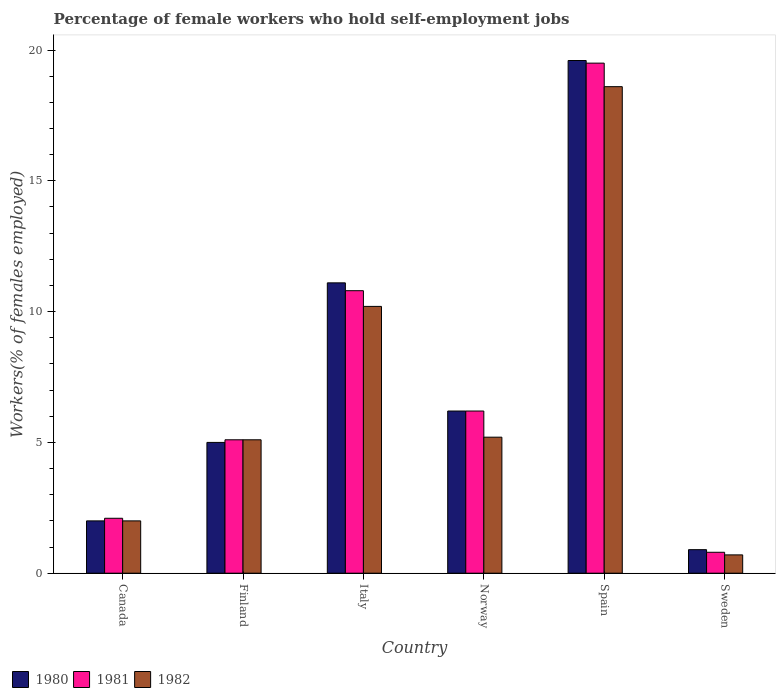How many different coloured bars are there?
Offer a terse response. 3. Are the number of bars per tick equal to the number of legend labels?
Your answer should be compact. Yes. Are the number of bars on each tick of the X-axis equal?
Give a very brief answer. Yes. What is the percentage of self-employed female workers in 1981 in Norway?
Offer a very short reply. 6.2. Across all countries, what is the maximum percentage of self-employed female workers in 1982?
Make the answer very short. 18.6. Across all countries, what is the minimum percentage of self-employed female workers in 1982?
Provide a short and direct response. 0.7. What is the total percentage of self-employed female workers in 1980 in the graph?
Keep it short and to the point. 44.8. What is the difference between the percentage of self-employed female workers in 1982 in Finland and that in Italy?
Your answer should be very brief. -5.1. What is the difference between the percentage of self-employed female workers in 1981 in Finland and the percentage of self-employed female workers in 1980 in Sweden?
Give a very brief answer. 4.2. What is the average percentage of self-employed female workers in 1980 per country?
Offer a very short reply. 7.47. What is the difference between the percentage of self-employed female workers of/in 1982 and percentage of self-employed female workers of/in 1980 in Norway?
Your answer should be compact. -1. What is the ratio of the percentage of self-employed female workers in 1982 in Finland to that in Spain?
Keep it short and to the point. 0.27. Is the percentage of self-employed female workers in 1980 in Canada less than that in Spain?
Keep it short and to the point. Yes. Is the difference between the percentage of self-employed female workers in 1982 in Italy and Norway greater than the difference between the percentage of self-employed female workers in 1980 in Italy and Norway?
Your answer should be very brief. Yes. What is the difference between the highest and the second highest percentage of self-employed female workers in 1982?
Offer a very short reply. 8.4. What is the difference between the highest and the lowest percentage of self-employed female workers in 1980?
Give a very brief answer. 18.7. In how many countries, is the percentage of self-employed female workers in 1982 greater than the average percentage of self-employed female workers in 1982 taken over all countries?
Give a very brief answer. 2. Is the sum of the percentage of self-employed female workers in 1982 in Canada and Norway greater than the maximum percentage of self-employed female workers in 1981 across all countries?
Your answer should be very brief. No. What does the 3rd bar from the right in Finland represents?
Offer a terse response. 1980. How many bars are there?
Provide a short and direct response. 18. Are all the bars in the graph horizontal?
Give a very brief answer. No. How many countries are there in the graph?
Keep it short and to the point. 6. What is the difference between two consecutive major ticks on the Y-axis?
Provide a short and direct response. 5. Are the values on the major ticks of Y-axis written in scientific E-notation?
Give a very brief answer. No. Does the graph contain grids?
Give a very brief answer. No. How many legend labels are there?
Provide a short and direct response. 3. How are the legend labels stacked?
Give a very brief answer. Horizontal. What is the title of the graph?
Ensure brevity in your answer.  Percentage of female workers who hold self-employment jobs. What is the label or title of the Y-axis?
Keep it short and to the point. Workers(% of females employed). What is the Workers(% of females employed) in 1980 in Canada?
Offer a very short reply. 2. What is the Workers(% of females employed) of 1981 in Canada?
Provide a succinct answer. 2.1. What is the Workers(% of females employed) of 1981 in Finland?
Provide a short and direct response. 5.1. What is the Workers(% of females employed) of 1982 in Finland?
Your response must be concise. 5.1. What is the Workers(% of females employed) of 1980 in Italy?
Provide a succinct answer. 11.1. What is the Workers(% of females employed) of 1981 in Italy?
Give a very brief answer. 10.8. What is the Workers(% of females employed) in 1982 in Italy?
Make the answer very short. 10.2. What is the Workers(% of females employed) of 1980 in Norway?
Offer a very short reply. 6.2. What is the Workers(% of females employed) of 1981 in Norway?
Your response must be concise. 6.2. What is the Workers(% of females employed) of 1982 in Norway?
Give a very brief answer. 5.2. What is the Workers(% of females employed) of 1980 in Spain?
Keep it short and to the point. 19.6. What is the Workers(% of females employed) in 1981 in Spain?
Make the answer very short. 19.5. What is the Workers(% of females employed) in 1982 in Spain?
Ensure brevity in your answer.  18.6. What is the Workers(% of females employed) in 1980 in Sweden?
Your answer should be very brief. 0.9. What is the Workers(% of females employed) of 1981 in Sweden?
Keep it short and to the point. 0.8. What is the Workers(% of females employed) in 1982 in Sweden?
Your response must be concise. 0.7. Across all countries, what is the maximum Workers(% of females employed) of 1980?
Offer a very short reply. 19.6. Across all countries, what is the maximum Workers(% of females employed) of 1982?
Offer a terse response. 18.6. Across all countries, what is the minimum Workers(% of females employed) of 1980?
Your response must be concise. 0.9. Across all countries, what is the minimum Workers(% of females employed) in 1981?
Ensure brevity in your answer.  0.8. Across all countries, what is the minimum Workers(% of females employed) in 1982?
Offer a terse response. 0.7. What is the total Workers(% of females employed) of 1980 in the graph?
Offer a terse response. 44.8. What is the total Workers(% of females employed) of 1981 in the graph?
Provide a succinct answer. 44.5. What is the total Workers(% of females employed) of 1982 in the graph?
Your answer should be very brief. 41.8. What is the difference between the Workers(% of females employed) in 1980 in Canada and that in Italy?
Make the answer very short. -9.1. What is the difference between the Workers(% of females employed) of 1981 in Canada and that in Italy?
Provide a short and direct response. -8.7. What is the difference between the Workers(% of females employed) in 1982 in Canada and that in Italy?
Provide a short and direct response. -8.2. What is the difference between the Workers(% of females employed) in 1980 in Canada and that in Spain?
Give a very brief answer. -17.6. What is the difference between the Workers(% of females employed) of 1981 in Canada and that in Spain?
Provide a short and direct response. -17.4. What is the difference between the Workers(% of females employed) of 1982 in Canada and that in Spain?
Offer a very short reply. -16.6. What is the difference between the Workers(% of females employed) in 1982 in Canada and that in Sweden?
Your answer should be very brief. 1.3. What is the difference between the Workers(% of females employed) of 1982 in Finland and that in Italy?
Your answer should be compact. -5.1. What is the difference between the Workers(% of females employed) in 1980 in Finland and that in Norway?
Offer a terse response. -1.2. What is the difference between the Workers(% of females employed) in 1981 in Finland and that in Norway?
Give a very brief answer. -1.1. What is the difference between the Workers(% of females employed) in 1980 in Finland and that in Spain?
Your answer should be compact. -14.6. What is the difference between the Workers(% of females employed) in 1981 in Finland and that in Spain?
Offer a very short reply. -14.4. What is the difference between the Workers(% of females employed) of 1982 in Finland and that in Spain?
Ensure brevity in your answer.  -13.5. What is the difference between the Workers(% of females employed) in 1981 in Finland and that in Sweden?
Provide a succinct answer. 4.3. What is the difference between the Workers(% of females employed) in 1982 in Finland and that in Sweden?
Your answer should be very brief. 4.4. What is the difference between the Workers(% of females employed) of 1980 in Italy and that in Norway?
Your answer should be compact. 4.9. What is the difference between the Workers(% of females employed) in 1982 in Italy and that in Norway?
Offer a terse response. 5. What is the difference between the Workers(% of females employed) of 1980 in Italy and that in Spain?
Ensure brevity in your answer.  -8.5. What is the difference between the Workers(% of females employed) in 1981 in Italy and that in Sweden?
Offer a terse response. 10. What is the difference between the Workers(% of females employed) in 1982 in Italy and that in Sweden?
Keep it short and to the point. 9.5. What is the difference between the Workers(% of females employed) in 1980 in Norway and that in Spain?
Give a very brief answer. -13.4. What is the difference between the Workers(% of females employed) in 1981 in Norway and that in Spain?
Your answer should be compact. -13.3. What is the difference between the Workers(% of females employed) in 1982 in Norway and that in Sweden?
Your response must be concise. 4.5. What is the difference between the Workers(% of females employed) in 1980 in Spain and that in Sweden?
Offer a terse response. 18.7. What is the difference between the Workers(% of females employed) of 1980 in Canada and the Workers(% of females employed) of 1981 in Finland?
Make the answer very short. -3.1. What is the difference between the Workers(% of females employed) of 1980 in Canada and the Workers(% of females employed) of 1982 in Finland?
Offer a terse response. -3.1. What is the difference between the Workers(% of females employed) in 1981 in Canada and the Workers(% of females employed) in 1982 in Finland?
Provide a succinct answer. -3. What is the difference between the Workers(% of females employed) in 1980 in Canada and the Workers(% of females employed) in 1982 in Italy?
Give a very brief answer. -8.2. What is the difference between the Workers(% of females employed) in 1981 in Canada and the Workers(% of females employed) in 1982 in Italy?
Ensure brevity in your answer.  -8.1. What is the difference between the Workers(% of females employed) in 1980 in Canada and the Workers(% of females employed) in 1981 in Spain?
Your response must be concise. -17.5. What is the difference between the Workers(% of females employed) in 1980 in Canada and the Workers(% of females employed) in 1982 in Spain?
Offer a very short reply. -16.6. What is the difference between the Workers(% of females employed) in 1981 in Canada and the Workers(% of females employed) in 1982 in Spain?
Provide a short and direct response. -16.5. What is the difference between the Workers(% of females employed) in 1980 in Canada and the Workers(% of females employed) in 1982 in Sweden?
Your answer should be compact. 1.3. What is the difference between the Workers(% of females employed) of 1981 in Canada and the Workers(% of females employed) of 1982 in Sweden?
Ensure brevity in your answer.  1.4. What is the difference between the Workers(% of females employed) of 1980 in Finland and the Workers(% of females employed) of 1981 in Italy?
Offer a terse response. -5.8. What is the difference between the Workers(% of females employed) in 1980 in Finland and the Workers(% of females employed) in 1982 in Italy?
Provide a succinct answer. -5.2. What is the difference between the Workers(% of females employed) in 1980 in Finland and the Workers(% of females employed) in 1981 in Spain?
Provide a short and direct response. -14.5. What is the difference between the Workers(% of females employed) of 1981 in Finland and the Workers(% of females employed) of 1982 in Spain?
Offer a terse response. -13.5. What is the difference between the Workers(% of females employed) of 1980 in Finland and the Workers(% of females employed) of 1981 in Sweden?
Make the answer very short. 4.2. What is the difference between the Workers(% of females employed) in 1980 in Italy and the Workers(% of females employed) in 1982 in Norway?
Make the answer very short. 5.9. What is the difference between the Workers(% of females employed) in 1981 in Italy and the Workers(% of females employed) in 1982 in Norway?
Provide a short and direct response. 5.6. What is the difference between the Workers(% of females employed) in 1980 in Italy and the Workers(% of females employed) in 1981 in Spain?
Give a very brief answer. -8.4. What is the difference between the Workers(% of females employed) in 1981 in Italy and the Workers(% of females employed) in 1982 in Spain?
Provide a short and direct response. -7.8. What is the difference between the Workers(% of females employed) in 1980 in Italy and the Workers(% of females employed) in 1981 in Sweden?
Offer a very short reply. 10.3. What is the difference between the Workers(% of females employed) in 1980 in Italy and the Workers(% of females employed) in 1982 in Sweden?
Offer a very short reply. 10.4. What is the difference between the Workers(% of females employed) of 1980 in Norway and the Workers(% of females employed) of 1981 in Spain?
Offer a terse response. -13.3. What is the difference between the Workers(% of females employed) in 1980 in Norway and the Workers(% of females employed) in 1982 in Spain?
Ensure brevity in your answer.  -12.4. What is the difference between the Workers(% of females employed) in 1981 in Norway and the Workers(% of females employed) in 1982 in Spain?
Ensure brevity in your answer.  -12.4. What is the difference between the Workers(% of females employed) of 1980 in Norway and the Workers(% of females employed) of 1981 in Sweden?
Your answer should be compact. 5.4. What is the difference between the Workers(% of females employed) of 1980 in Spain and the Workers(% of females employed) of 1981 in Sweden?
Your answer should be very brief. 18.8. What is the average Workers(% of females employed) of 1980 per country?
Your response must be concise. 7.47. What is the average Workers(% of females employed) of 1981 per country?
Provide a short and direct response. 7.42. What is the average Workers(% of females employed) in 1982 per country?
Give a very brief answer. 6.97. What is the difference between the Workers(% of females employed) in 1980 and Workers(% of females employed) in 1982 in Canada?
Keep it short and to the point. 0. What is the difference between the Workers(% of females employed) in 1981 and Workers(% of females employed) in 1982 in Canada?
Offer a very short reply. 0.1. What is the difference between the Workers(% of females employed) in 1980 and Workers(% of females employed) in 1982 in Finland?
Keep it short and to the point. -0.1. What is the difference between the Workers(% of females employed) in 1981 and Workers(% of females employed) in 1982 in Finland?
Give a very brief answer. 0. What is the difference between the Workers(% of females employed) in 1981 and Workers(% of females employed) in 1982 in Italy?
Provide a succinct answer. 0.6. What is the difference between the Workers(% of females employed) in 1980 and Workers(% of females employed) in 1981 in Norway?
Offer a terse response. 0. What is the difference between the Workers(% of females employed) in 1981 and Workers(% of females employed) in 1982 in Norway?
Your answer should be very brief. 1. What is the difference between the Workers(% of females employed) in 1980 and Workers(% of females employed) in 1982 in Spain?
Give a very brief answer. 1. What is the difference between the Workers(% of females employed) of 1980 and Workers(% of females employed) of 1982 in Sweden?
Give a very brief answer. 0.2. What is the difference between the Workers(% of females employed) in 1981 and Workers(% of females employed) in 1982 in Sweden?
Offer a very short reply. 0.1. What is the ratio of the Workers(% of females employed) in 1981 in Canada to that in Finland?
Your answer should be compact. 0.41. What is the ratio of the Workers(% of females employed) in 1982 in Canada to that in Finland?
Your answer should be compact. 0.39. What is the ratio of the Workers(% of females employed) in 1980 in Canada to that in Italy?
Make the answer very short. 0.18. What is the ratio of the Workers(% of females employed) in 1981 in Canada to that in Italy?
Offer a terse response. 0.19. What is the ratio of the Workers(% of females employed) of 1982 in Canada to that in Italy?
Your answer should be very brief. 0.2. What is the ratio of the Workers(% of females employed) of 1980 in Canada to that in Norway?
Provide a succinct answer. 0.32. What is the ratio of the Workers(% of females employed) of 1981 in Canada to that in Norway?
Provide a succinct answer. 0.34. What is the ratio of the Workers(% of females employed) of 1982 in Canada to that in Norway?
Give a very brief answer. 0.38. What is the ratio of the Workers(% of females employed) of 1980 in Canada to that in Spain?
Give a very brief answer. 0.1. What is the ratio of the Workers(% of females employed) in 1981 in Canada to that in Spain?
Keep it short and to the point. 0.11. What is the ratio of the Workers(% of females employed) in 1982 in Canada to that in Spain?
Give a very brief answer. 0.11. What is the ratio of the Workers(% of females employed) of 1980 in Canada to that in Sweden?
Your answer should be very brief. 2.22. What is the ratio of the Workers(% of females employed) in 1981 in Canada to that in Sweden?
Provide a short and direct response. 2.62. What is the ratio of the Workers(% of females employed) in 1982 in Canada to that in Sweden?
Offer a terse response. 2.86. What is the ratio of the Workers(% of females employed) of 1980 in Finland to that in Italy?
Your response must be concise. 0.45. What is the ratio of the Workers(% of females employed) of 1981 in Finland to that in Italy?
Provide a short and direct response. 0.47. What is the ratio of the Workers(% of females employed) in 1980 in Finland to that in Norway?
Your response must be concise. 0.81. What is the ratio of the Workers(% of females employed) in 1981 in Finland to that in Norway?
Offer a terse response. 0.82. What is the ratio of the Workers(% of females employed) of 1982 in Finland to that in Norway?
Provide a short and direct response. 0.98. What is the ratio of the Workers(% of females employed) of 1980 in Finland to that in Spain?
Keep it short and to the point. 0.26. What is the ratio of the Workers(% of females employed) of 1981 in Finland to that in Spain?
Offer a terse response. 0.26. What is the ratio of the Workers(% of females employed) of 1982 in Finland to that in Spain?
Ensure brevity in your answer.  0.27. What is the ratio of the Workers(% of females employed) of 1980 in Finland to that in Sweden?
Your answer should be compact. 5.56. What is the ratio of the Workers(% of females employed) in 1981 in Finland to that in Sweden?
Ensure brevity in your answer.  6.38. What is the ratio of the Workers(% of females employed) of 1982 in Finland to that in Sweden?
Ensure brevity in your answer.  7.29. What is the ratio of the Workers(% of females employed) of 1980 in Italy to that in Norway?
Your response must be concise. 1.79. What is the ratio of the Workers(% of females employed) in 1981 in Italy to that in Norway?
Provide a short and direct response. 1.74. What is the ratio of the Workers(% of females employed) of 1982 in Italy to that in Norway?
Provide a short and direct response. 1.96. What is the ratio of the Workers(% of females employed) in 1980 in Italy to that in Spain?
Offer a very short reply. 0.57. What is the ratio of the Workers(% of females employed) in 1981 in Italy to that in Spain?
Offer a terse response. 0.55. What is the ratio of the Workers(% of females employed) in 1982 in Italy to that in Spain?
Keep it short and to the point. 0.55. What is the ratio of the Workers(% of females employed) of 1980 in Italy to that in Sweden?
Offer a very short reply. 12.33. What is the ratio of the Workers(% of females employed) of 1981 in Italy to that in Sweden?
Ensure brevity in your answer.  13.5. What is the ratio of the Workers(% of females employed) in 1982 in Italy to that in Sweden?
Make the answer very short. 14.57. What is the ratio of the Workers(% of females employed) of 1980 in Norway to that in Spain?
Ensure brevity in your answer.  0.32. What is the ratio of the Workers(% of females employed) of 1981 in Norway to that in Spain?
Offer a very short reply. 0.32. What is the ratio of the Workers(% of females employed) in 1982 in Norway to that in Spain?
Your response must be concise. 0.28. What is the ratio of the Workers(% of females employed) of 1980 in Norway to that in Sweden?
Give a very brief answer. 6.89. What is the ratio of the Workers(% of females employed) in 1981 in Norway to that in Sweden?
Offer a terse response. 7.75. What is the ratio of the Workers(% of females employed) of 1982 in Norway to that in Sweden?
Your answer should be very brief. 7.43. What is the ratio of the Workers(% of females employed) of 1980 in Spain to that in Sweden?
Give a very brief answer. 21.78. What is the ratio of the Workers(% of females employed) in 1981 in Spain to that in Sweden?
Keep it short and to the point. 24.38. What is the ratio of the Workers(% of females employed) in 1982 in Spain to that in Sweden?
Ensure brevity in your answer.  26.57. What is the difference between the highest and the second highest Workers(% of females employed) of 1982?
Offer a very short reply. 8.4. What is the difference between the highest and the lowest Workers(% of females employed) in 1981?
Ensure brevity in your answer.  18.7. 